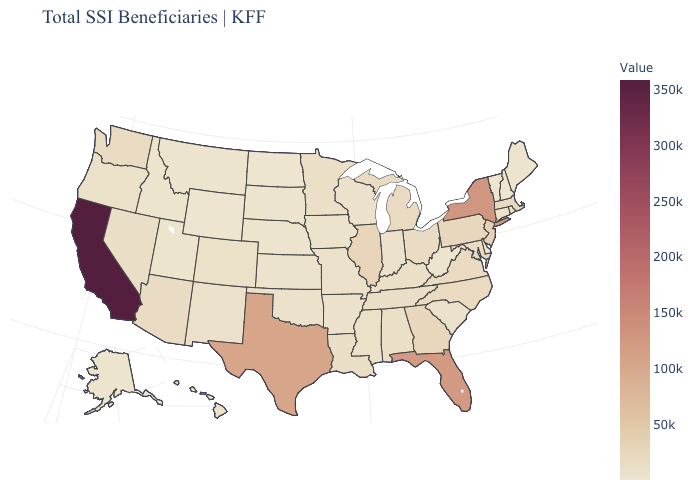Which states have the lowest value in the USA?
Keep it brief. Wyoming. Does Kansas have the highest value in the USA?
Give a very brief answer. No. 